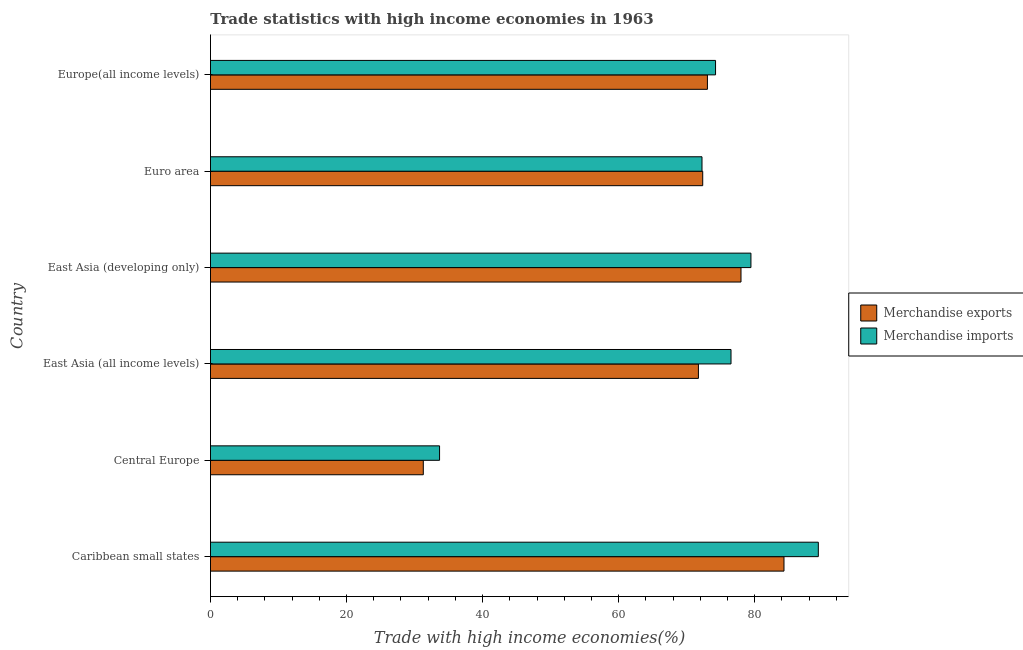How many different coloured bars are there?
Provide a succinct answer. 2. How many groups of bars are there?
Your answer should be very brief. 6. Are the number of bars per tick equal to the number of legend labels?
Your response must be concise. Yes. How many bars are there on the 5th tick from the top?
Your answer should be compact. 2. What is the label of the 1st group of bars from the top?
Your response must be concise. Europe(all income levels). What is the merchandise imports in Euro area?
Keep it short and to the point. 72.25. Across all countries, what is the maximum merchandise imports?
Your response must be concise. 89.35. Across all countries, what is the minimum merchandise exports?
Ensure brevity in your answer.  31.28. In which country was the merchandise exports maximum?
Offer a very short reply. Caribbean small states. In which country was the merchandise imports minimum?
Offer a terse response. Central Europe. What is the total merchandise imports in the graph?
Offer a very short reply. 425.48. What is the difference between the merchandise exports in East Asia (all income levels) and that in Euro area?
Provide a succinct answer. -0.63. What is the difference between the merchandise imports in Central Europe and the merchandise exports in Caribbean small states?
Provide a succinct answer. -50.63. What is the average merchandise imports per country?
Offer a terse response. 70.91. What is the difference between the merchandise imports and merchandise exports in East Asia (all income levels)?
Give a very brief answer. 4.79. What is the ratio of the merchandise exports in Caribbean small states to that in East Asia (developing only)?
Keep it short and to the point. 1.08. Is the difference between the merchandise exports in Euro area and Europe(all income levels) greater than the difference between the merchandise imports in Euro area and Europe(all income levels)?
Your answer should be compact. Yes. What is the difference between the highest and the second highest merchandise exports?
Make the answer very short. 6.32. What is the difference between the highest and the lowest merchandise imports?
Ensure brevity in your answer.  55.68. Is the sum of the merchandise exports in East Asia (developing only) and Europe(all income levels) greater than the maximum merchandise imports across all countries?
Offer a very short reply. Yes. How many bars are there?
Offer a terse response. 12. Are all the bars in the graph horizontal?
Offer a terse response. Yes. How many countries are there in the graph?
Your answer should be very brief. 6. What is the difference between two consecutive major ticks on the X-axis?
Keep it short and to the point. 20. Does the graph contain grids?
Your answer should be compact. No. How many legend labels are there?
Give a very brief answer. 2. How are the legend labels stacked?
Your answer should be compact. Vertical. What is the title of the graph?
Offer a terse response. Trade statistics with high income economies in 1963. What is the label or title of the X-axis?
Offer a very short reply. Trade with high income economies(%). What is the label or title of the Y-axis?
Your answer should be very brief. Country. What is the Trade with high income economies(%) in Merchandise exports in Caribbean small states?
Provide a succinct answer. 84.3. What is the Trade with high income economies(%) in Merchandise imports in Caribbean small states?
Ensure brevity in your answer.  89.35. What is the Trade with high income economies(%) in Merchandise exports in Central Europe?
Your response must be concise. 31.28. What is the Trade with high income economies(%) of Merchandise imports in Central Europe?
Ensure brevity in your answer.  33.68. What is the Trade with high income economies(%) in Merchandise exports in East Asia (all income levels)?
Keep it short and to the point. 71.72. What is the Trade with high income economies(%) of Merchandise imports in East Asia (all income levels)?
Your answer should be very brief. 76.52. What is the Trade with high income economies(%) of Merchandise exports in East Asia (developing only)?
Ensure brevity in your answer.  77.98. What is the Trade with high income economies(%) in Merchandise imports in East Asia (developing only)?
Your answer should be very brief. 79.44. What is the Trade with high income economies(%) in Merchandise exports in Euro area?
Provide a short and direct response. 72.36. What is the Trade with high income economies(%) in Merchandise imports in Euro area?
Make the answer very short. 72.25. What is the Trade with high income economies(%) of Merchandise exports in Europe(all income levels)?
Make the answer very short. 73.05. What is the Trade with high income economies(%) of Merchandise imports in Europe(all income levels)?
Ensure brevity in your answer.  74.24. Across all countries, what is the maximum Trade with high income economies(%) in Merchandise exports?
Your answer should be very brief. 84.3. Across all countries, what is the maximum Trade with high income economies(%) in Merchandise imports?
Provide a short and direct response. 89.35. Across all countries, what is the minimum Trade with high income economies(%) of Merchandise exports?
Your answer should be very brief. 31.28. Across all countries, what is the minimum Trade with high income economies(%) in Merchandise imports?
Make the answer very short. 33.68. What is the total Trade with high income economies(%) of Merchandise exports in the graph?
Your response must be concise. 410.7. What is the total Trade with high income economies(%) of Merchandise imports in the graph?
Your response must be concise. 425.48. What is the difference between the Trade with high income economies(%) of Merchandise exports in Caribbean small states and that in Central Europe?
Provide a succinct answer. 53.02. What is the difference between the Trade with high income economies(%) of Merchandise imports in Caribbean small states and that in Central Europe?
Make the answer very short. 55.68. What is the difference between the Trade with high income economies(%) of Merchandise exports in Caribbean small states and that in East Asia (all income levels)?
Offer a terse response. 12.58. What is the difference between the Trade with high income economies(%) of Merchandise imports in Caribbean small states and that in East Asia (all income levels)?
Offer a very short reply. 12.84. What is the difference between the Trade with high income economies(%) in Merchandise exports in Caribbean small states and that in East Asia (developing only)?
Offer a terse response. 6.32. What is the difference between the Trade with high income economies(%) in Merchandise imports in Caribbean small states and that in East Asia (developing only)?
Your answer should be very brief. 9.91. What is the difference between the Trade with high income economies(%) in Merchandise exports in Caribbean small states and that in Euro area?
Give a very brief answer. 11.94. What is the difference between the Trade with high income economies(%) of Merchandise imports in Caribbean small states and that in Euro area?
Make the answer very short. 17.1. What is the difference between the Trade with high income economies(%) in Merchandise exports in Caribbean small states and that in Europe(all income levels)?
Offer a terse response. 11.25. What is the difference between the Trade with high income economies(%) in Merchandise imports in Caribbean small states and that in Europe(all income levels)?
Your answer should be very brief. 15.11. What is the difference between the Trade with high income economies(%) of Merchandise exports in Central Europe and that in East Asia (all income levels)?
Provide a succinct answer. -40.44. What is the difference between the Trade with high income economies(%) in Merchandise imports in Central Europe and that in East Asia (all income levels)?
Give a very brief answer. -42.84. What is the difference between the Trade with high income economies(%) of Merchandise exports in Central Europe and that in East Asia (developing only)?
Ensure brevity in your answer.  -46.7. What is the difference between the Trade with high income economies(%) of Merchandise imports in Central Europe and that in East Asia (developing only)?
Offer a terse response. -45.77. What is the difference between the Trade with high income economies(%) of Merchandise exports in Central Europe and that in Euro area?
Provide a short and direct response. -41.07. What is the difference between the Trade with high income economies(%) in Merchandise imports in Central Europe and that in Euro area?
Offer a very short reply. -38.58. What is the difference between the Trade with high income economies(%) of Merchandise exports in Central Europe and that in Europe(all income levels)?
Offer a terse response. -41.76. What is the difference between the Trade with high income economies(%) of Merchandise imports in Central Europe and that in Europe(all income levels)?
Give a very brief answer. -40.57. What is the difference between the Trade with high income economies(%) in Merchandise exports in East Asia (all income levels) and that in East Asia (developing only)?
Your answer should be very brief. -6.26. What is the difference between the Trade with high income economies(%) in Merchandise imports in East Asia (all income levels) and that in East Asia (developing only)?
Keep it short and to the point. -2.93. What is the difference between the Trade with high income economies(%) in Merchandise exports in East Asia (all income levels) and that in Euro area?
Your answer should be very brief. -0.63. What is the difference between the Trade with high income economies(%) in Merchandise imports in East Asia (all income levels) and that in Euro area?
Offer a terse response. 4.26. What is the difference between the Trade with high income economies(%) of Merchandise exports in East Asia (all income levels) and that in Europe(all income levels)?
Give a very brief answer. -1.32. What is the difference between the Trade with high income economies(%) in Merchandise imports in East Asia (all income levels) and that in Europe(all income levels)?
Ensure brevity in your answer.  2.27. What is the difference between the Trade with high income economies(%) of Merchandise exports in East Asia (developing only) and that in Euro area?
Give a very brief answer. 5.63. What is the difference between the Trade with high income economies(%) in Merchandise imports in East Asia (developing only) and that in Euro area?
Make the answer very short. 7.19. What is the difference between the Trade with high income economies(%) of Merchandise exports in East Asia (developing only) and that in Europe(all income levels)?
Your answer should be compact. 4.94. What is the difference between the Trade with high income economies(%) of Merchandise imports in East Asia (developing only) and that in Europe(all income levels)?
Your response must be concise. 5.2. What is the difference between the Trade with high income economies(%) of Merchandise exports in Euro area and that in Europe(all income levels)?
Offer a very short reply. -0.69. What is the difference between the Trade with high income economies(%) in Merchandise imports in Euro area and that in Europe(all income levels)?
Give a very brief answer. -1.99. What is the difference between the Trade with high income economies(%) of Merchandise exports in Caribbean small states and the Trade with high income economies(%) of Merchandise imports in Central Europe?
Give a very brief answer. 50.63. What is the difference between the Trade with high income economies(%) in Merchandise exports in Caribbean small states and the Trade with high income economies(%) in Merchandise imports in East Asia (all income levels)?
Give a very brief answer. 7.79. What is the difference between the Trade with high income economies(%) of Merchandise exports in Caribbean small states and the Trade with high income economies(%) of Merchandise imports in East Asia (developing only)?
Offer a very short reply. 4.86. What is the difference between the Trade with high income economies(%) of Merchandise exports in Caribbean small states and the Trade with high income economies(%) of Merchandise imports in Euro area?
Your answer should be compact. 12.05. What is the difference between the Trade with high income economies(%) of Merchandise exports in Caribbean small states and the Trade with high income economies(%) of Merchandise imports in Europe(all income levels)?
Your response must be concise. 10.06. What is the difference between the Trade with high income economies(%) in Merchandise exports in Central Europe and the Trade with high income economies(%) in Merchandise imports in East Asia (all income levels)?
Provide a succinct answer. -45.23. What is the difference between the Trade with high income economies(%) in Merchandise exports in Central Europe and the Trade with high income economies(%) in Merchandise imports in East Asia (developing only)?
Keep it short and to the point. -48.16. What is the difference between the Trade with high income economies(%) in Merchandise exports in Central Europe and the Trade with high income economies(%) in Merchandise imports in Euro area?
Ensure brevity in your answer.  -40.97. What is the difference between the Trade with high income economies(%) in Merchandise exports in Central Europe and the Trade with high income economies(%) in Merchandise imports in Europe(all income levels)?
Keep it short and to the point. -42.96. What is the difference between the Trade with high income economies(%) of Merchandise exports in East Asia (all income levels) and the Trade with high income economies(%) of Merchandise imports in East Asia (developing only)?
Your answer should be compact. -7.72. What is the difference between the Trade with high income economies(%) in Merchandise exports in East Asia (all income levels) and the Trade with high income economies(%) in Merchandise imports in Euro area?
Your response must be concise. -0.53. What is the difference between the Trade with high income economies(%) in Merchandise exports in East Asia (all income levels) and the Trade with high income economies(%) in Merchandise imports in Europe(all income levels)?
Give a very brief answer. -2.52. What is the difference between the Trade with high income economies(%) in Merchandise exports in East Asia (developing only) and the Trade with high income economies(%) in Merchandise imports in Euro area?
Offer a terse response. 5.73. What is the difference between the Trade with high income economies(%) in Merchandise exports in East Asia (developing only) and the Trade with high income economies(%) in Merchandise imports in Europe(all income levels)?
Offer a very short reply. 3.74. What is the difference between the Trade with high income economies(%) of Merchandise exports in Euro area and the Trade with high income economies(%) of Merchandise imports in Europe(all income levels)?
Your answer should be very brief. -1.89. What is the average Trade with high income economies(%) in Merchandise exports per country?
Offer a very short reply. 68.45. What is the average Trade with high income economies(%) of Merchandise imports per country?
Provide a succinct answer. 70.91. What is the difference between the Trade with high income economies(%) of Merchandise exports and Trade with high income economies(%) of Merchandise imports in Caribbean small states?
Provide a short and direct response. -5.05. What is the difference between the Trade with high income economies(%) of Merchandise exports and Trade with high income economies(%) of Merchandise imports in Central Europe?
Give a very brief answer. -2.39. What is the difference between the Trade with high income economies(%) in Merchandise exports and Trade with high income economies(%) in Merchandise imports in East Asia (all income levels)?
Keep it short and to the point. -4.79. What is the difference between the Trade with high income economies(%) in Merchandise exports and Trade with high income economies(%) in Merchandise imports in East Asia (developing only)?
Offer a very short reply. -1.46. What is the difference between the Trade with high income economies(%) in Merchandise exports and Trade with high income economies(%) in Merchandise imports in Euro area?
Ensure brevity in your answer.  0.11. What is the difference between the Trade with high income economies(%) in Merchandise exports and Trade with high income economies(%) in Merchandise imports in Europe(all income levels)?
Offer a very short reply. -1.2. What is the ratio of the Trade with high income economies(%) in Merchandise exports in Caribbean small states to that in Central Europe?
Make the answer very short. 2.69. What is the ratio of the Trade with high income economies(%) of Merchandise imports in Caribbean small states to that in Central Europe?
Ensure brevity in your answer.  2.65. What is the ratio of the Trade with high income economies(%) in Merchandise exports in Caribbean small states to that in East Asia (all income levels)?
Your answer should be compact. 1.18. What is the ratio of the Trade with high income economies(%) in Merchandise imports in Caribbean small states to that in East Asia (all income levels)?
Your answer should be very brief. 1.17. What is the ratio of the Trade with high income economies(%) in Merchandise exports in Caribbean small states to that in East Asia (developing only)?
Your answer should be very brief. 1.08. What is the ratio of the Trade with high income economies(%) in Merchandise imports in Caribbean small states to that in East Asia (developing only)?
Offer a terse response. 1.12. What is the ratio of the Trade with high income economies(%) in Merchandise exports in Caribbean small states to that in Euro area?
Ensure brevity in your answer.  1.17. What is the ratio of the Trade with high income economies(%) of Merchandise imports in Caribbean small states to that in Euro area?
Give a very brief answer. 1.24. What is the ratio of the Trade with high income economies(%) in Merchandise exports in Caribbean small states to that in Europe(all income levels)?
Your response must be concise. 1.15. What is the ratio of the Trade with high income economies(%) of Merchandise imports in Caribbean small states to that in Europe(all income levels)?
Your response must be concise. 1.2. What is the ratio of the Trade with high income economies(%) in Merchandise exports in Central Europe to that in East Asia (all income levels)?
Offer a very short reply. 0.44. What is the ratio of the Trade with high income economies(%) in Merchandise imports in Central Europe to that in East Asia (all income levels)?
Provide a succinct answer. 0.44. What is the ratio of the Trade with high income economies(%) of Merchandise exports in Central Europe to that in East Asia (developing only)?
Offer a terse response. 0.4. What is the ratio of the Trade with high income economies(%) of Merchandise imports in Central Europe to that in East Asia (developing only)?
Make the answer very short. 0.42. What is the ratio of the Trade with high income economies(%) of Merchandise exports in Central Europe to that in Euro area?
Ensure brevity in your answer.  0.43. What is the ratio of the Trade with high income economies(%) of Merchandise imports in Central Europe to that in Euro area?
Your answer should be compact. 0.47. What is the ratio of the Trade with high income economies(%) of Merchandise exports in Central Europe to that in Europe(all income levels)?
Your answer should be very brief. 0.43. What is the ratio of the Trade with high income economies(%) in Merchandise imports in Central Europe to that in Europe(all income levels)?
Offer a terse response. 0.45. What is the ratio of the Trade with high income economies(%) in Merchandise exports in East Asia (all income levels) to that in East Asia (developing only)?
Keep it short and to the point. 0.92. What is the ratio of the Trade with high income economies(%) of Merchandise imports in East Asia (all income levels) to that in East Asia (developing only)?
Give a very brief answer. 0.96. What is the ratio of the Trade with high income economies(%) in Merchandise imports in East Asia (all income levels) to that in Euro area?
Offer a terse response. 1.06. What is the ratio of the Trade with high income economies(%) of Merchandise exports in East Asia (all income levels) to that in Europe(all income levels)?
Your response must be concise. 0.98. What is the ratio of the Trade with high income economies(%) of Merchandise imports in East Asia (all income levels) to that in Europe(all income levels)?
Ensure brevity in your answer.  1.03. What is the ratio of the Trade with high income economies(%) of Merchandise exports in East Asia (developing only) to that in Euro area?
Your response must be concise. 1.08. What is the ratio of the Trade with high income economies(%) of Merchandise imports in East Asia (developing only) to that in Euro area?
Offer a very short reply. 1.1. What is the ratio of the Trade with high income economies(%) of Merchandise exports in East Asia (developing only) to that in Europe(all income levels)?
Your response must be concise. 1.07. What is the ratio of the Trade with high income economies(%) of Merchandise imports in East Asia (developing only) to that in Europe(all income levels)?
Offer a terse response. 1.07. What is the ratio of the Trade with high income economies(%) of Merchandise exports in Euro area to that in Europe(all income levels)?
Your answer should be compact. 0.99. What is the ratio of the Trade with high income economies(%) of Merchandise imports in Euro area to that in Europe(all income levels)?
Your answer should be compact. 0.97. What is the difference between the highest and the second highest Trade with high income economies(%) in Merchandise exports?
Provide a short and direct response. 6.32. What is the difference between the highest and the second highest Trade with high income economies(%) of Merchandise imports?
Provide a short and direct response. 9.91. What is the difference between the highest and the lowest Trade with high income economies(%) in Merchandise exports?
Your answer should be very brief. 53.02. What is the difference between the highest and the lowest Trade with high income economies(%) of Merchandise imports?
Your answer should be compact. 55.68. 